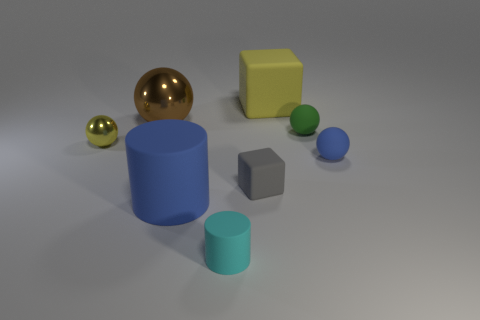Add 1 big blue spheres. How many objects exist? 9 Subtract all gray blocks. How many blocks are left? 1 Subtract 2 cylinders. How many cylinders are left? 0 Add 2 big yellow objects. How many big yellow objects exist? 3 Subtract all large brown metallic spheres. How many spheres are left? 3 Subtract 0 green cylinders. How many objects are left? 8 Subtract all blocks. How many objects are left? 6 Subtract all cyan cylinders. Subtract all blue balls. How many cylinders are left? 1 Subtract all green spheres. How many cyan cylinders are left? 1 Subtract all large red matte things. Subtract all cyan things. How many objects are left? 7 